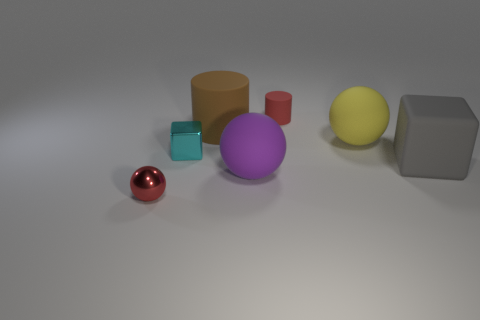Are there any cylinders of the same size as the gray thing?
Your answer should be very brief. Yes. What number of cyan shiny objects have the same shape as the gray rubber object?
Ensure brevity in your answer.  1. Are there an equal number of rubber things that are in front of the big gray object and big things in front of the tiny red sphere?
Provide a succinct answer. No. Are any small cylinders visible?
Provide a succinct answer. Yes. What size is the rubber ball in front of the block to the right of the large yellow ball behind the purple rubber thing?
Offer a terse response. Large. What is the shape of the shiny object that is the same size as the shiny block?
Offer a very short reply. Sphere. Is there anything else that has the same material as the big brown object?
Provide a short and direct response. Yes. How many objects are either large things to the left of the large purple ball or rubber things?
Your answer should be very brief. 5. There is a red object that is on the right side of the tiny red thing in front of the small cyan metallic block; are there any tiny red cylinders that are right of it?
Offer a terse response. No. What number of big green metallic blocks are there?
Give a very brief answer. 0. 